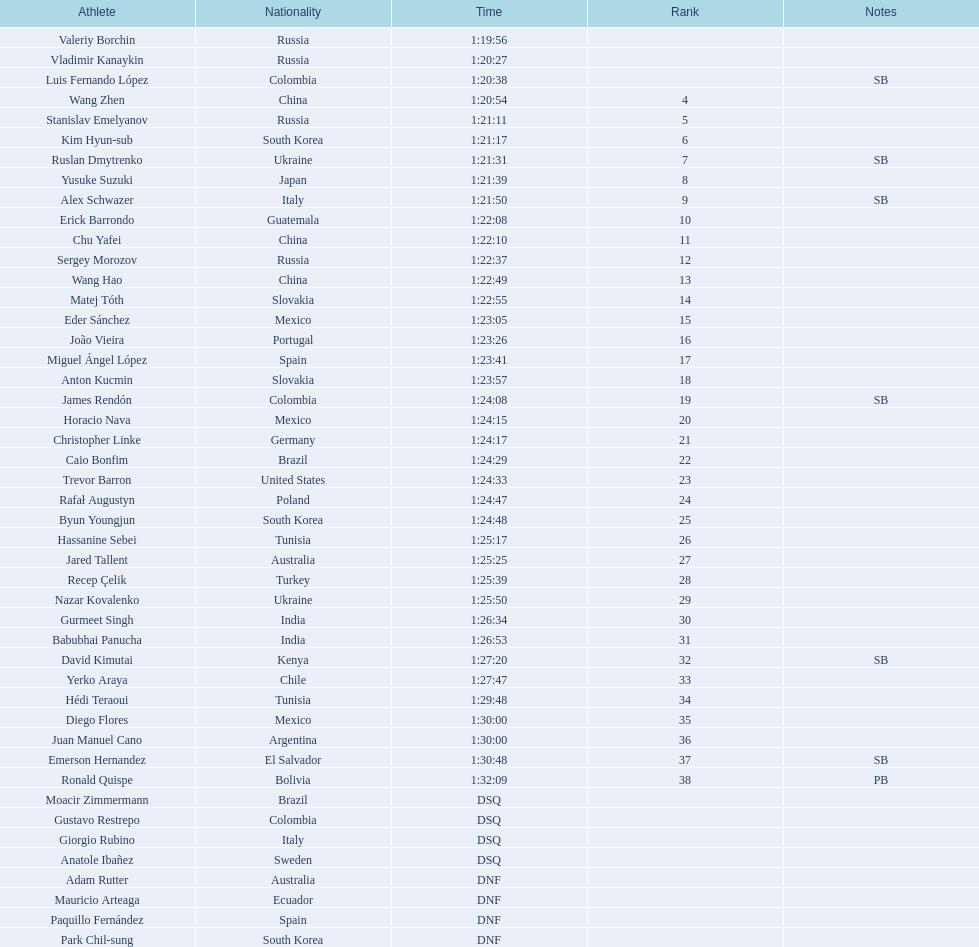Name all athletes were slower than horacio nava. Christopher Linke, Caio Bonfim, Trevor Barron, Rafał Augustyn, Byun Youngjun, Hassanine Sebei, Jared Tallent, Recep Çelik, Nazar Kovalenko, Gurmeet Singh, Babubhai Panucha, David Kimutai, Yerko Araya, Hédi Teraoui, Diego Flores, Juan Manuel Cano, Emerson Hernandez, Ronald Quispe. 